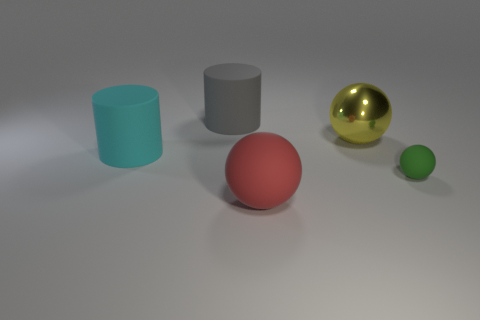What is the size of the green sphere that is the same material as the large cyan cylinder?
Offer a very short reply. Small. Is there any other thing that has the same size as the gray rubber cylinder?
Offer a very short reply. Yes. Is there any other thing that is the same shape as the red thing?
Your response must be concise. Yes. Is the number of matte balls that are on the right side of the yellow ball greater than the number of red balls?
Your response must be concise. No. There is a big cylinder in front of the large gray object; what number of big shiny spheres are behind it?
Keep it short and to the point. 1. The big cyan rubber object that is behind the sphere that is on the left side of the sphere that is behind the cyan rubber object is what shape?
Keep it short and to the point. Cylinder. How big is the metallic object?
Provide a short and direct response. Large. Are there any yellow objects made of the same material as the big red thing?
Give a very brief answer. No. There is a yellow thing that is the same shape as the red matte thing; what size is it?
Provide a short and direct response. Large. Is the number of large rubber things left of the gray rubber thing the same as the number of red objects?
Give a very brief answer. Yes. 